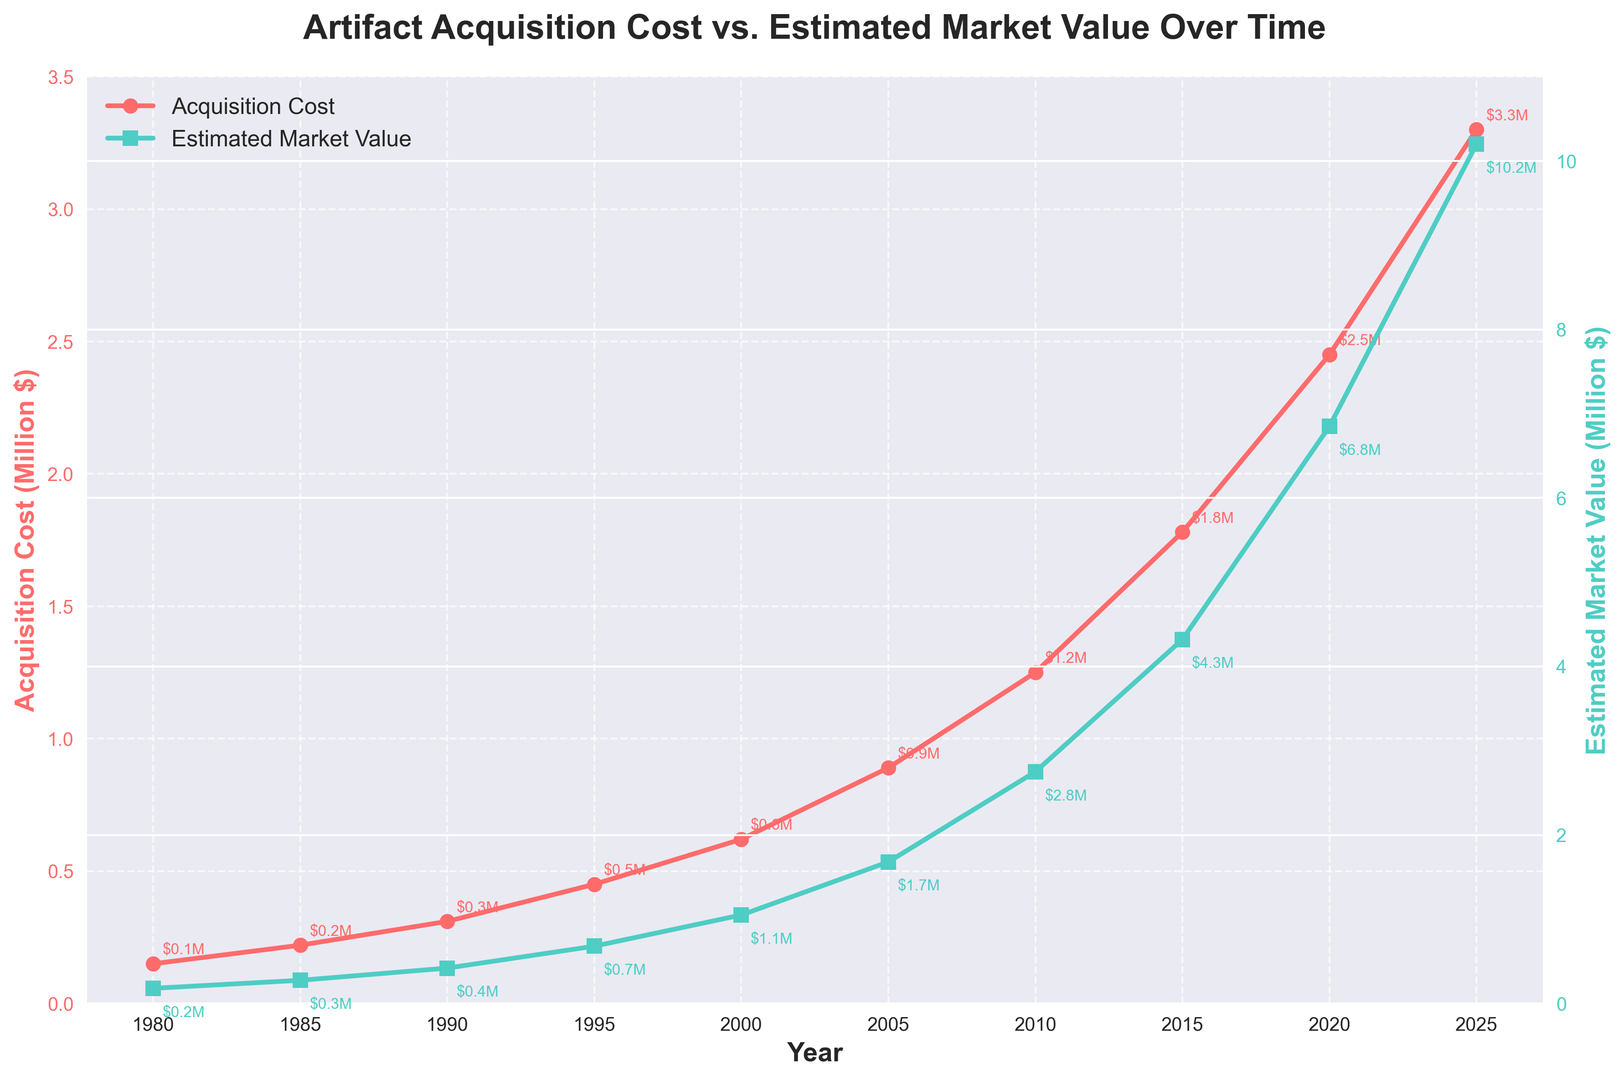How does the gap between Acquisition Cost and Estimated Market Value change over time? To determine this, we need to observe the difference between the two lines (Acquisition Cost and Estimated Market Value) on the graph. The gap appears to widen over time, illustrating that the Estimated Market Value grows much faster than the Acquisition Cost.
Answer: It widens over time In which year did the Acquisition Cost cross the 1 million dollar mark? According to the chart, we can see that the Acquisition Cost line crosses the 1 million dollar mark between 2005 and 2010. On closer inspection, it is in the year 2010, where the Acquisition Cost is 1.25 million dollars.
Answer: 2010 What was the difference between the Estimated Market Value and the Acquisition Cost in 2020? Referring to the plotted points for the year 2020, the Acquisition Cost is 2.45 million dollars and the Estimated Market Value is 6.85 million dollars. The difference is 6.85 - 2.45 = 4.40 million dollars.
Answer: 4.40 million dollars How many years does it take for the Estimated Market Value to be four times the Acquisition Cost? Observing the plot, in the year 1980, the Estimated Market Value (0.18 million dollars) is just 1.2 times the Acquisition Cost (0.15 million dollars). When Acquisition Cost is around 1.78 million dollars in 2015, Estimated Market Value becomes 4.32 million dollars, slightly more than four times the Acquisition Cost, signifying roughly 35 years.
Answer: 35 years Does there come a point where the Acquisition Cost eventually meets or exceeds the Estimated Market Value? Observing the chart, the Estimated Market Value line consistently remains above the Acquisition Cost line throughout the years. There are no points where the Acquisition Cost meets or exceeds the Estimated Market Value.
Answer: No Between 1985 and 1995, in which year did the Acquisition Cost increase the most? Examining the points for these years, the Acquisition Cost increased from 0.22 million dollars in 1985 to 0.31 million in 1990 (an increase of 0.09 million), and from 0.31 million in 1990 to 0.45 million in 1995 (an increase of 0.14 million). Thus, the year with the larger increase is from 1990 to 1995.
Answer: 1995 By how much did the Estimated Market Value increase from 2000 to 2025? Looking at the plot, the Estimated Market Value in 2000 is 1.05 million dollars, and in 2025, it is 10.2 million dollars. The increase is calculated as 10.2 - 1.05 = 9.15 million dollars.
Answer: 9.15 million dollars 